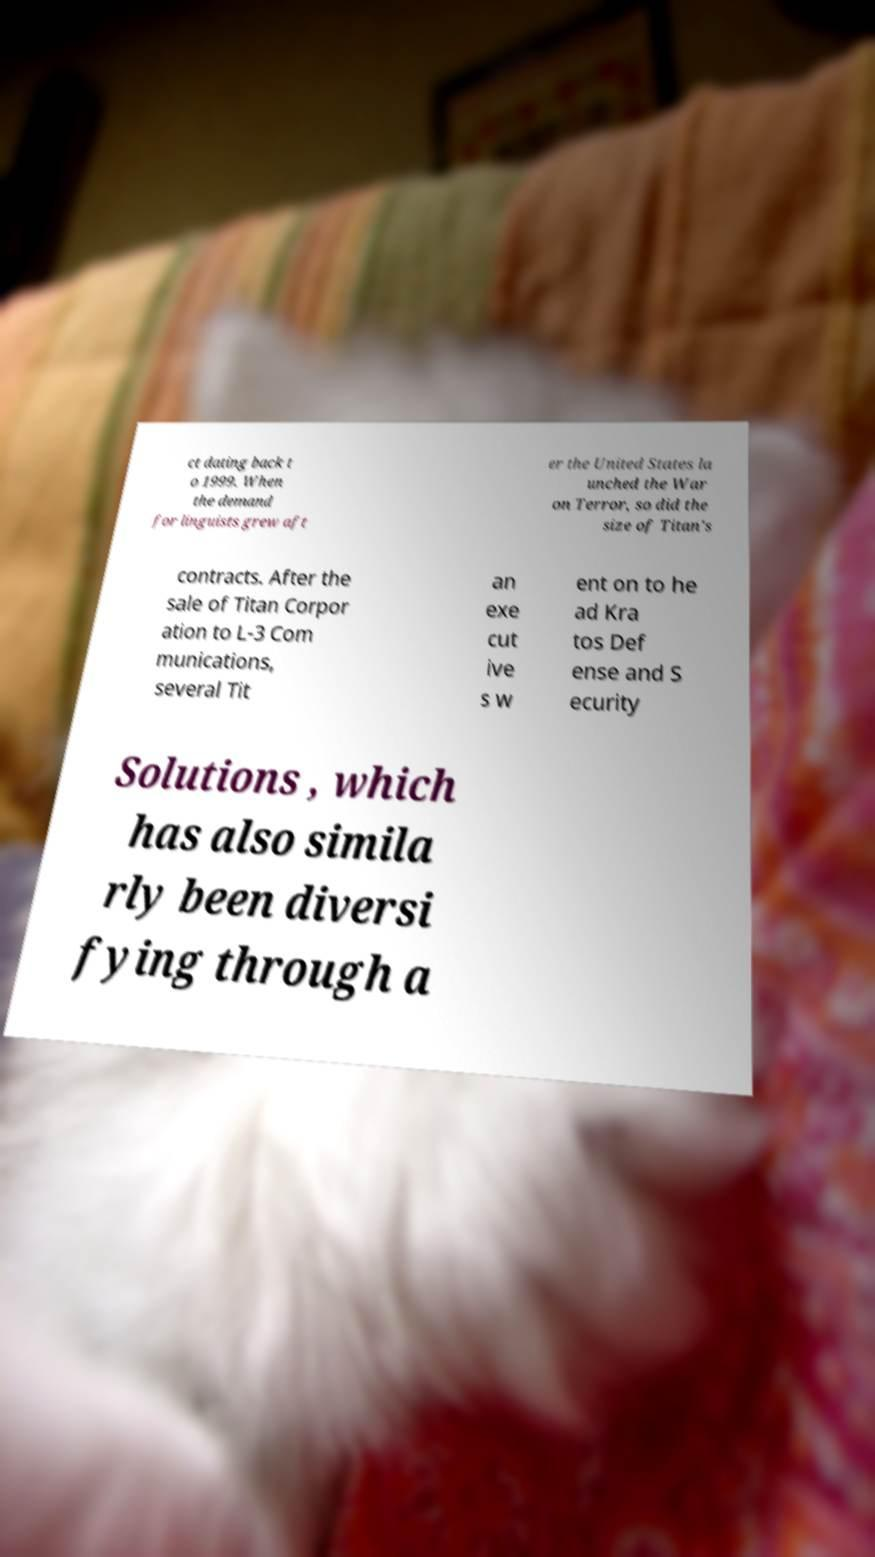For documentation purposes, I need the text within this image transcribed. Could you provide that? ct dating back t o 1999. When the demand for linguists grew aft er the United States la unched the War on Terror, so did the size of Titan's contracts. After the sale of Titan Corpor ation to L-3 Com munications, several Tit an exe cut ive s w ent on to he ad Kra tos Def ense and S ecurity Solutions , which has also simila rly been diversi fying through a 